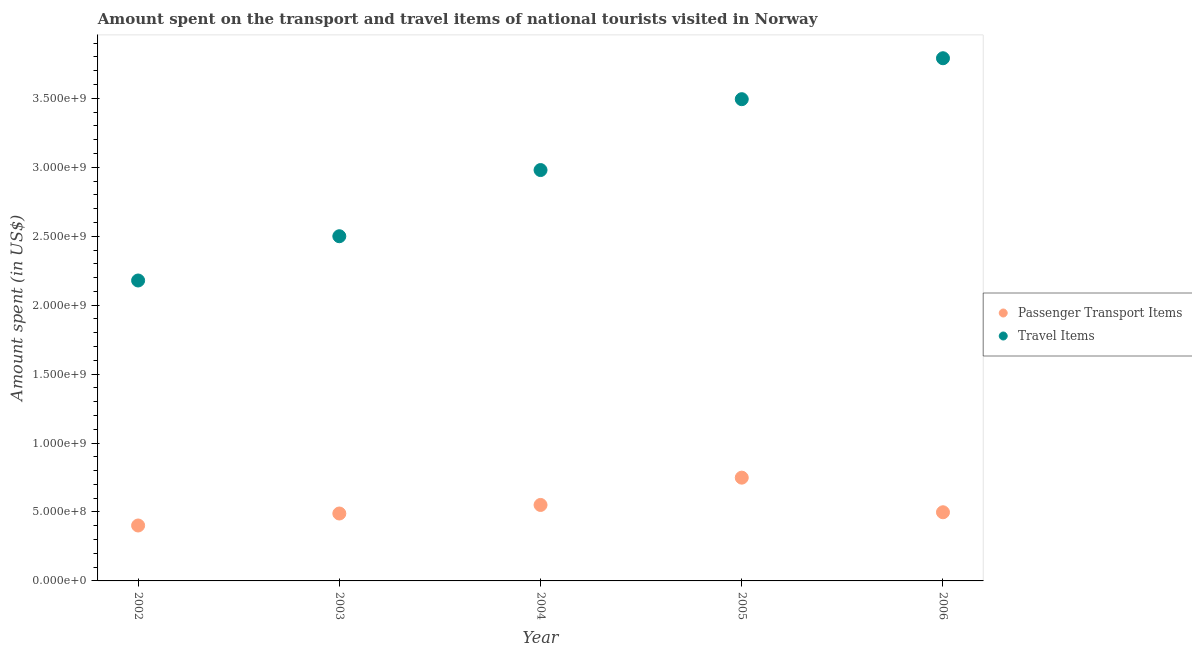How many different coloured dotlines are there?
Give a very brief answer. 2. What is the amount spent on passenger transport items in 2003?
Make the answer very short. 4.89e+08. Across all years, what is the maximum amount spent on passenger transport items?
Offer a very short reply. 7.49e+08. Across all years, what is the minimum amount spent on passenger transport items?
Provide a short and direct response. 4.02e+08. In which year was the amount spent in travel items maximum?
Ensure brevity in your answer.  2006. In which year was the amount spent in travel items minimum?
Your answer should be compact. 2002. What is the total amount spent in travel items in the graph?
Offer a terse response. 1.49e+1. What is the difference between the amount spent on passenger transport items in 2002 and that in 2003?
Your answer should be very brief. -8.70e+07. What is the difference between the amount spent in travel items in 2004 and the amount spent on passenger transport items in 2005?
Offer a very short reply. 2.23e+09. What is the average amount spent in travel items per year?
Offer a very short reply. 2.99e+09. In the year 2003, what is the difference between the amount spent on passenger transport items and amount spent in travel items?
Your response must be concise. -2.01e+09. In how many years, is the amount spent in travel items greater than 700000000 US$?
Keep it short and to the point. 5. What is the ratio of the amount spent on passenger transport items in 2002 to that in 2003?
Make the answer very short. 0.82. Is the difference between the amount spent in travel items in 2003 and 2006 greater than the difference between the amount spent on passenger transport items in 2003 and 2006?
Ensure brevity in your answer.  No. What is the difference between the highest and the second highest amount spent on passenger transport items?
Your response must be concise. 1.98e+08. What is the difference between the highest and the lowest amount spent in travel items?
Offer a very short reply. 1.61e+09. Does the amount spent on passenger transport items monotonically increase over the years?
Ensure brevity in your answer.  No. Is the amount spent in travel items strictly greater than the amount spent on passenger transport items over the years?
Make the answer very short. Yes. What is the difference between two consecutive major ticks on the Y-axis?
Keep it short and to the point. 5.00e+08. Does the graph contain any zero values?
Your answer should be compact. No. Where does the legend appear in the graph?
Provide a short and direct response. Center right. How many legend labels are there?
Your answer should be compact. 2. What is the title of the graph?
Keep it short and to the point. Amount spent on the transport and travel items of national tourists visited in Norway. What is the label or title of the Y-axis?
Your response must be concise. Amount spent (in US$). What is the Amount spent (in US$) of Passenger Transport Items in 2002?
Your answer should be compact. 4.02e+08. What is the Amount spent (in US$) in Travel Items in 2002?
Keep it short and to the point. 2.18e+09. What is the Amount spent (in US$) of Passenger Transport Items in 2003?
Your response must be concise. 4.89e+08. What is the Amount spent (in US$) of Travel Items in 2003?
Offer a very short reply. 2.50e+09. What is the Amount spent (in US$) in Passenger Transport Items in 2004?
Give a very brief answer. 5.51e+08. What is the Amount spent (in US$) in Travel Items in 2004?
Make the answer very short. 2.98e+09. What is the Amount spent (in US$) in Passenger Transport Items in 2005?
Your response must be concise. 7.49e+08. What is the Amount spent (in US$) of Travel Items in 2005?
Offer a terse response. 3.49e+09. What is the Amount spent (in US$) of Passenger Transport Items in 2006?
Your answer should be compact. 4.98e+08. What is the Amount spent (in US$) of Travel Items in 2006?
Your response must be concise. 3.79e+09. Across all years, what is the maximum Amount spent (in US$) of Passenger Transport Items?
Keep it short and to the point. 7.49e+08. Across all years, what is the maximum Amount spent (in US$) of Travel Items?
Keep it short and to the point. 3.79e+09. Across all years, what is the minimum Amount spent (in US$) of Passenger Transport Items?
Offer a terse response. 4.02e+08. Across all years, what is the minimum Amount spent (in US$) of Travel Items?
Your answer should be very brief. 2.18e+09. What is the total Amount spent (in US$) of Passenger Transport Items in the graph?
Your response must be concise. 2.69e+09. What is the total Amount spent (in US$) of Travel Items in the graph?
Offer a very short reply. 1.49e+1. What is the difference between the Amount spent (in US$) in Passenger Transport Items in 2002 and that in 2003?
Ensure brevity in your answer.  -8.70e+07. What is the difference between the Amount spent (in US$) in Travel Items in 2002 and that in 2003?
Keep it short and to the point. -3.21e+08. What is the difference between the Amount spent (in US$) in Passenger Transport Items in 2002 and that in 2004?
Make the answer very short. -1.49e+08. What is the difference between the Amount spent (in US$) in Travel Items in 2002 and that in 2004?
Ensure brevity in your answer.  -8.01e+08. What is the difference between the Amount spent (in US$) in Passenger Transport Items in 2002 and that in 2005?
Give a very brief answer. -3.47e+08. What is the difference between the Amount spent (in US$) in Travel Items in 2002 and that in 2005?
Provide a succinct answer. -1.32e+09. What is the difference between the Amount spent (in US$) of Passenger Transport Items in 2002 and that in 2006?
Provide a succinct answer. -9.60e+07. What is the difference between the Amount spent (in US$) in Travel Items in 2002 and that in 2006?
Ensure brevity in your answer.  -1.61e+09. What is the difference between the Amount spent (in US$) in Passenger Transport Items in 2003 and that in 2004?
Give a very brief answer. -6.20e+07. What is the difference between the Amount spent (in US$) of Travel Items in 2003 and that in 2004?
Your answer should be very brief. -4.80e+08. What is the difference between the Amount spent (in US$) of Passenger Transport Items in 2003 and that in 2005?
Provide a short and direct response. -2.60e+08. What is the difference between the Amount spent (in US$) of Travel Items in 2003 and that in 2005?
Your answer should be compact. -9.94e+08. What is the difference between the Amount spent (in US$) in Passenger Transport Items in 2003 and that in 2006?
Your answer should be very brief. -9.00e+06. What is the difference between the Amount spent (in US$) in Travel Items in 2003 and that in 2006?
Make the answer very short. -1.29e+09. What is the difference between the Amount spent (in US$) of Passenger Transport Items in 2004 and that in 2005?
Provide a succinct answer. -1.98e+08. What is the difference between the Amount spent (in US$) of Travel Items in 2004 and that in 2005?
Your response must be concise. -5.14e+08. What is the difference between the Amount spent (in US$) in Passenger Transport Items in 2004 and that in 2006?
Provide a succinct answer. 5.30e+07. What is the difference between the Amount spent (in US$) of Travel Items in 2004 and that in 2006?
Make the answer very short. -8.11e+08. What is the difference between the Amount spent (in US$) of Passenger Transport Items in 2005 and that in 2006?
Offer a very short reply. 2.51e+08. What is the difference between the Amount spent (in US$) in Travel Items in 2005 and that in 2006?
Your answer should be very brief. -2.97e+08. What is the difference between the Amount spent (in US$) of Passenger Transport Items in 2002 and the Amount spent (in US$) of Travel Items in 2003?
Make the answer very short. -2.10e+09. What is the difference between the Amount spent (in US$) in Passenger Transport Items in 2002 and the Amount spent (in US$) in Travel Items in 2004?
Your answer should be very brief. -2.58e+09. What is the difference between the Amount spent (in US$) in Passenger Transport Items in 2002 and the Amount spent (in US$) in Travel Items in 2005?
Make the answer very short. -3.09e+09. What is the difference between the Amount spent (in US$) of Passenger Transport Items in 2002 and the Amount spent (in US$) of Travel Items in 2006?
Make the answer very short. -3.39e+09. What is the difference between the Amount spent (in US$) of Passenger Transport Items in 2003 and the Amount spent (in US$) of Travel Items in 2004?
Ensure brevity in your answer.  -2.49e+09. What is the difference between the Amount spent (in US$) in Passenger Transport Items in 2003 and the Amount spent (in US$) in Travel Items in 2005?
Ensure brevity in your answer.  -3.00e+09. What is the difference between the Amount spent (in US$) of Passenger Transport Items in 2003 and the Amount spent (in US$) of Travel Items in 2006?
Make the answer very short. -3.30e+09. What is the difference between the Amount spent (in US$) of Passenger Transport Items in 2004 and the Amount spent (in US$) of Travel Items in 2005?
Give a very brief answer. -2.94e+09. What is the difference between the Amount spent (in US$) in Passenger Transport Items in 2004 and the Amount spent (in US$) in Travel Items in 2006?
Offer a terse response. -3.24e+09. What is the difference between the Amount spent (in US$) in Passenger Transport Items in 2005 and the Amount spent (in US$) in Travel Items in 2006?
Provide a short and direct response. -3.04e+09. What is the average Amount spent (in US$) of Passenger Transport Items per year?
Keep it short and to the point. 5.38e+08. What is the average Amount spent (in US$) in Travel Items per year?
Make the answer very short. 2.99e+09. In the year 2002, what is the difference between the Amount spent (in US$) in Passenger Transport Items and Amount spent (in US$) in Travel Items?
Your answer should be compact. -1.78e+09. In the year 2003, what is the difference between the Amount spent (in US$) in Passenger Transport Items and Amount spent (in US$) in Travel Items?
Make the answer very short. -2.01e+09. In the year 2004, what is the difference between the Amount spent (in US$) in Passenger Transport Items and Amount spent (in US$) in Travel Items?
Provide a succinct answer. -2.43e+09. In the year 2005, what is the difference between the Amount spent (in US$) of Passenger Transport Items and Amount spent (in US$) of Travel Items?
Provide a short and direct response. -2.74e+09. In the year 2006, what is the difference between the Amount spent (in US$) of Passenger Transport Items and Amount spent (in US$) of Travel Items?
Provide a succinct answer. -3.29e+09. What is the ratio of the Amount spent (in US$) of Passenger Transport Items in 2002 to that in 2003?
Your response must be concise. 0.82. What is the ratio of the Amount spent (in US$) of Travel Items in 2002 to that in 2003?
Make the answer very short. 0.87. What is the ratio of the Amount spent (in US$) in Passenger Transport Items in 2002 to that in 2004?
Offer a very short reply. 0.73. What is the ratio of the Amount spent (in US$) of Travel Items in 2002 to that in 2004?
Your answer should be compact. 0.73. What is the ratio of the Amount spent (in US$) of Passenger Transport Items in 2002 to that in 2005?
Offer a very short reply. 0.54. What is the ratio of the Amount spent (in US$) of Travel Items in 2002 to that in 2005?
Give a very brief answer. 0.62. What is the ratio of the Amount spent (in US$) of Passenger Transport Items in 2002 to that in 2006?
Make the answer very short. 0.81. What is the ratio of the Amount spent (in US$) in Travel Items in 2002 to that in 2006?
Offer a very short reply. 0.57. What is the ratio of the Amount spent (in US$) in Passenger Transport Items in 2003 to that in 2004?
Ensure brevity in your answer.  0.89. What is the ratio of the Amount spent (in US$) in Travel Items in 2003 to that in 2004?
Ensure brevity in your answer.  0.84. What is the ratio of the Amount spent (in US$) of Passenger Transport Items in 2003 to that in 2005?
Provide a succinct answer. 0.65. What is the ratio of the Amount spent (in US$) in Travel Items in 2003 to that in 2005?
Provide a succinct answer. 0.72. What is the ratio of the Amount spent (in US$) of Passenger Transport Items in 2003 to that in 2006?
Provide a succinct answer. 0.98. What is the ratio of the Amount spent (in US$) in Travel Items in 2003 to that in 2006?
Keep it short and to the point. 0.66. What is the ratio of the Amount spent (in US$) in Passenger Transport Items in 2004 to that in 2005?
Give a very brief answer. 0.74. What is the ratio of the Amount spent (in US$) in Travel Items in 2004 to that in 2005?
Your answer should be compact. 0.85. What is the ratio of the Amount spent (in US$) of Passenger Transport Items in 2004 to that in 2006?
Provide a short and direct response. 1.11. What is the ratio of the Amount spent (in US$) in Travel Items in 2004 to that in 2006?
Your answer should be compact. 0.79. What is the ratio of the Amount spent (in US$) in Passenger Transport Items in 2005 to that in 2006?
Provide a short and direct response. 1.5. What is the ratio of the Amount spent (in US$) of Travel Items in 2005 to that in 2006?
Give a very brief answer. 0.92. What is the difference between the highest and the second highest Amount spent (in US$) in Passenger Transport Items?
Offer a terse response. 1.98e+08. What is the difference between the highest and the second highest Amount spent (in US$) in Travel Items?
Your answer should be very brief. 2.97e+08. What is the difference between the highest and the lowest Amount spent (in US$) of Passenger Transport Items?
Offer a very short reply. 3.47e+08. What is the difference between the highest and the lowest Amount spent (in US$) of Travel Items?
Ensure brevity in your answer.  1.61e+09. 